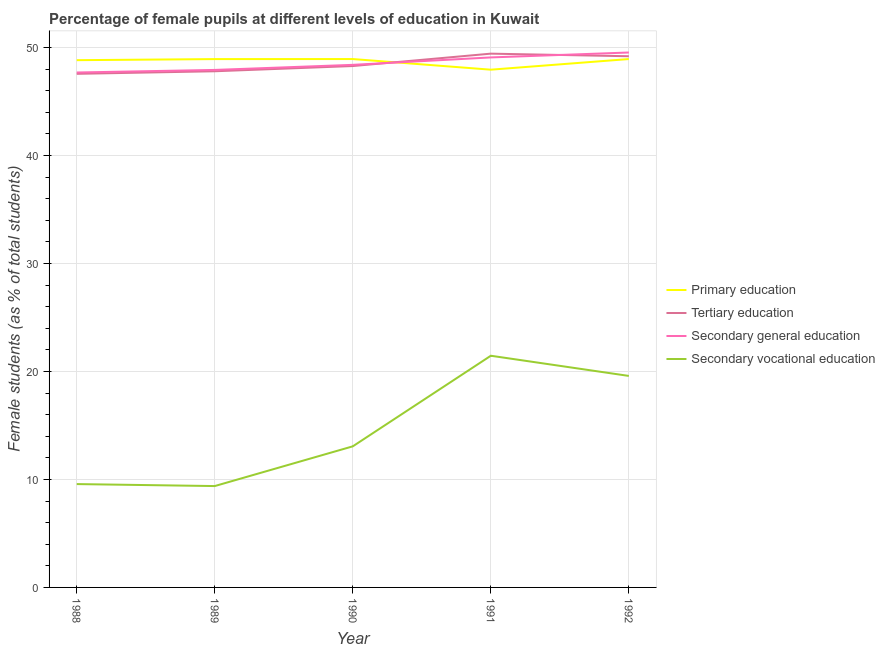Is the number of lines equal to the number of legend labels?
Provide a short and direct response. Yes. What is the percentage of female students in secondary vocational education in 1988?
Keep it short and to the point. 9.57. Across all years, what is the maximum percentage of female students in secondary education?
Your answer should be very brief. 49.53. Across all years, what is the minimum percentage of female students in tertiary education?
Keep it short and to the point. 47.55. In which year was the percentage of female students in secondary vocational education minimum?
Provide a succinct answer. 1989. What is the total percentage of female students in primary education in the graph?
Your response must be concise. 243.52. What is the difference between the percentage of female students in secondary vocational education in 1989 and that in 1991?
Offer a terse response. -12.07. What is the difference between the percentage of female students in tertiary education in 1991 and the percentage of female students in secondary education in 1990?
Your answer should be compact. 1.04. What is the average percentage of female students in secondary vocational education per year?
Your answer should be very brief. 14.61. In the year 1988, what is the difference between the percentage of female students in secondary vocational education and percentage of female students in primary education?
Offer a very short reply. -39.25. What is the ratio of the percentage of female students in primary education in 1990 to that in 1992?
Keep it short and to the point. 1. What is the difference between the highest and the second highest percentage of female students in tertiary education?
Provide a succinct answer. 0.24. What is the difference between the highest and the lowest percentage of female students in primary education?
Provide a short and direct response. 0.98. Is the sum of the percentage of female students in secondary vocational education in 1990 and 1992 greater than the maximum percentage of female students in secondary education across all years?
Provide a short and direct response. No. Is it the case that in every year, the sum of the percentage of female students in secondary education and percentage of female students in secondary vocational education is greater than the sum of percentage of female students in tertiary education and percentage of female students in primary education?
Your answer should be very brief. No. Is it the case that in every year, the sum of the percentage of female students in primary education and percentage of female students in tertiary education is greater than the percentage of female students in secondary education?
Offer a very short reply. Yes. Does the percentage of female students in secondary education monotonically increase over the years?
Your answer should be compact. Yes. How many years are there in the graph?
Ensure brevity in your answer.  5. Does the graph contain grids?
Your answer should be compact. Yes. Where does the legend appear in the graph?
Your answer should be very brief. Center right. How many legend labels are there?
Make the answer very short. 4. How are the legend labels stacked?
Your answer should be compact. Vertical. What is the title of the graph?
Make the answer very short. Percentage of female pupils at different levels of education in Kuwait. Does "Grants and Revenue" appear as one of the legend labels in the graph?
Give a very brief answer. No. What is the label or title of the X-axis?
Give a very brief answer. Year. What is the label or title of the Y-axis?
Offer a terse response. Female students (as % of total students). What is the Female students (as % of total students) of Primary education in 1988?
Offer a very short reply. 48.82. What is the Female students (as % of total students) in Tertiary education in 1988?
Offer a very short reply. 47.55. What is the Female students (as % of total students) of Secondary general education in 1988?
Give a very brief answer. 47.68. What is the Female students (as % of total students) of Secondary vocational education in 1988?
Give a very brief answer. 9.57. What is the Female students (as % of total students) in Primary education in 1989?
Make the answer very short. 48.92. What is the Female students (as % of total students) of Tertiary education in 1989?
Provide a succinct answer. 47.79. What is the Female students (as % of total students) of Secondary general education in 1989?
Provide a short and direct response. 47.92. What is the Female students (as % of total students) in Secondary vocational education in 1989?
Provide a short and direct response. 9.39. What is the Female students (as % of total students) of Primary education in 1990?
Provide a succinct answer. 48.92. What is the Female students (as % of total students) of Tertiary education in 1990?
Ensure brevity in your answer.  48.28. What is the Female students (as % of total students) of Secondary general education in 1990?
Keep it short and to the point. 48.38. What is the Female students (as % of total students) in Secondary vocational education in 1990?
Your answer should be very brief. 13.06. What is the Female students (as % of total students) in Primary education in 1991?
Give a very brief answer. 47.94. What is the Female students (as % of total students) in Tertiary education in 1991?
Your answer should be very brief. 49.42. What is the Female students (as % of total students) in Secondary general education in 1991?
Give a very brief answer. 49.07. What is the Female students (as % of total students) in Secondary vocational education in 1991?
Make the answer very short. 21.45. What is the Female students (as % of total students) of Primary education in 1992?
Offer a very short reply. 48.92. What is the Female students (as % of total students) in Tertiary education in 1992?
Keep it short and to the point. 49.18. What is the Female students (as % of total students) in Secondary general education in 1992?
Your answer should be very brief. 49.53. What is the Female students (as % of total students) in Secondary vocational education in 1992?
Your response must be concise. 19.58. Across all years, what is the maximum Female students (as % of total students) in Primary education?
Provide a succinct answer. 48.92. Across all years, what is the maximum Female students (as % of total students) in Tertiary education?
Make the answer very short. 49.42. Across all years, what is the maximum Female students (as % of total students) in Secondary general education?
Your response must be concise. 49.53. Across all years, what is the maximum Female students (as % of total students) in Secondary vocational education?
Keep it short and to the point. 21.45. Across all years, what is the minimum Female students (as % of total students) of Primary education?
Make the answer very short. 47.94. Across all years, what is the minimum Female students (as % of total students) in Tertiary education?
Ensure brevity in your answer.  47.55. Across all years, what is the minimum Female students (as % of total students) in Secondary general education?
Offer a very short reply. 47.68. Across all years, what is the minimum Female students (as % of total students) in Secondary vocational education?
Make the answer very short. 9.39. What is the total Female students (as % of total students) of Primary education in the graph?
Offer a very short reply. 243.52. What is the total Female students (as % of total students) of Tertiary education in the graph?
Make the answer very short. 242.22. What is the total Female students (as % of total students) of Secondary general education in the graph?
Give a very brief answer. 242.58. What is the total Female students (as % of total students) of Secondary vocational education in the graph?
Offer a terse response. 73.05. What is the difference between the Female students (as % of total students) of Primary education in 1988 and that in 1989?
Make the answer very short. -0.1. What is the difference between the Female students (as % of total students) of Tertiary education in 1988 and that in 1989?
Offer a very short reply. -0.24. What is the difference between the Female students (as % of total students) in Secondary general education in 1988 and that in 1989?
Offer a terse response. -0.24. What is the difference between the Female students (as % of total students) in Secondary vocational education in 1988 and that in 1989?
Offer a terse response. 0.18. What is the difference between the Female students (as % of total students) of Primary education in 1988 and that in 1990?
Provide a short and direct response. -0.1. What is the difference between the Female students (as % of total students) of Tertiary education in 1988 and that in 1990?
Provide a succinct answer. -0.72. What is the difference between the Female students (as % of total students) in Secondary general education in 1988 and that in 1990?
Your answer should be compact. -0.71. What is the difference between the Female students (as % of total students) in Secondary vocational education in 1988 and that in 1990?
Your answer should be very brief. -3.49. What is the difference between the Female students (as % of total students) in Primary education in 1988 and that in 1991?
Your answer should be very brief. 0.88. What is the difference between the Female students (as % of total students) of Tertiary education in 1988 and that in 1991?
Your answer should be very brief. -1.87. What is the difference between the Female students (as % of total students) in Secondary general education in 1988 and that in 1991?
Keep it short and to the point. -1.4. What is the difference between the Female students (as % of total students) in Secondary vocational education in 1988 and that in 1991?
Your response must be concise. -11.88. What is the difference between the Female students (as % of total students) in Primary education in 1988 and that in 1992?
Ensure brevity in your answer.  -0.1. What is the difference between the Female students (as % of total students) in Tertiary education in 1988 and that in 1992?
Ensure brevity in your answer.  -1.63. What is the difference between the Female students (as % of total students) of Secondary general education in 1988 and that in 1992?
Provide a short and direct response. -1.85. What is the difference between the Female students (as % of total students) in Secondary vocational education in 1988 and that in 1992?
Make the answer very short. -10.01. What is the difference between the Female students (as % of total students) in Primary education in 1989 and that in 1990?
Your answer should be very brief. -0. What is the difference between the Female students (as % of total students) in Tertiary education in 1989 and that in 1990?
Offer a very short reply. -0.48. What is the difference between the Female students (as % of total students) in Secondary general education in 1989 and that in 1990?
Offer a terse response. -0.47. What is the difference between the Female students (as % of total students) in Secondary vocational education in 1989 and that in 1990?
Your answer should be very brief. -3.68. What is the difference between the Female students (as % of total students) in Primary education in 1989 and that in 1991?
Ensure brevity in your answer.  0.98. What is the difference between the Female students (as % of total students) in Tertiary education in 1989 and that in 1991?
Ensure brevity in your answer.  -1.63. What is the difference between the Female students (as % of total students) of Secondary general education in 1989 and that in 1991?
Offer a very short reply. -1.16. What is the difference between the Female students (as % of total students) of Secondary vocational education in 1989 and that in 1991?
Provide a succinct answer. -12.07. What is the difference between the Female students (as % of total students) of Primary education in 1989 and that in 1992?
Your answer should be very brief. -0. What is the difference between the Female students (as % of total students) of Tertiary education in 1989 and that in 1992?
Make the answer very short. -1.39. What is the difference between the Female students (as % of total students) of Secondary general education in 1989 and that in 1992?
Your response must be concise. -1.61. What is the difference between the Female students (as % of total students) in Secondary vocational education in 1989 and that in 1992?
Ensure brevity in your answer.  -10.2. What is the difference between the Female students (as % of total students) of Primary education in 1990 and that in 1991?
Make the answer very short. 0.98. What is the difference between the Female students (as % of total students) in Tertiary education in 1990 and that in 1991?
Your response must be concise. -1.15. What is the difference between the Female students (as % of total students) of Secondary general education in 1990 and that in 1991?
Your response must be concise. -0.69. What is the difference between the Female students (as % of total students) in Secondary vocational education in 1990 and that in 1991?
Your answer should be compact. -8.39. What is the difference between the Female students (as % of total students) in Tertiary education in 1990 and that in 1992?
Make the answer very short. -0.91. What is the difference between the Female students (as % of total students) in Secondary general education in 1990 and that in 1992?
Offer a very short reply. -1.14. What is the difference between the Female students (as % of total students) of Secondary vocational education in 1990 and that in 1992?
Keep it short and to the point. -6.52. What is the difference between the Female students (as % of total students) of Primary education in 1991 and that in 1992?
Ensure brevity in your answer.  -0.98. What is the difference between the Female students (as % of total students) in Tertiary education in 1991 and that in 1992?
Provide a short and direct response. 0.24. What is the difference between the Female students (as % of total students) in Secondary general education in 1991 and that in 1992?
Offer a terse response. -0.46. What is the difference between the Female students (as % of total students) of Secondary vocational education in 1991 and that in 1992?
Offer a very short reply. 1.87. What is the difference between the Female students (as % of total students) of Primary education in 1988 and the Female students (as % of total students) of Tertiary education in 1989?
Make the answer very short. 1.03. What is the difference between the Female students (as % of total students) in Primary education in 1988 and the Female students (as % of total students) in Secondary general education in 1989?
Keep it short and to the point. 0.9. What is the difference between the Female students (as % of total students) of Primary education in 1988 and the Female students (as % of total students) of Secondary vocational education in 1989?
Offer a very short reply. 39.43. What is the difference between the Female students (as % of total students) in Tertiary education in 1988 and the Female students (as % of total students) in Secondary general education in 1989?
Offer a very short reply. -0.36. What is the difference between the Female students (as % of total students) in Tertiary education in 1988 and the Female students (as % of total students) in Secondary vocational education in 1989?
Offer a terse response. 38.17. What is the difference between the Female students (as % of total students) of Secondary general education in 1988 and the Female students (as % of total students) of Secondary vocational education in 1989?
Your answer should be very brief. 38.29. What is the difference between the Female students (as % of total students) in Primary education in 1988 and the Female students (as % of total students) in Tertiary education in 1990?
Your response must be concise. 0.54. What is the difference between the Female students (as % of total students) of Primary education in 1988 and the Female students (as % of total students) of Secondary general education in 1990?
Provide a succinct answer. 0.43. What is the difference between the Female students (as % of total students) of Primary education in 1988 and the Female students (as % of total students) of Secondary vocational education in 1990?
Offer a terse response. 35.75. What is the difference between the Female students (as % of total students) of Tertiary education in 1988 and the Female students (as % of total students) of Secondary general education in 1990?
Provide a succinct answer. -0.83. What is the difference between the Female students (as % of total students) of Tertiary education in 1988 and the Female students (as % of total students) of Secondary vocational education in 1990?
Your response must be concise. 34.49. What is the difference between the Female students (as % of total students) of Secondary general education in 1988 and the Female students (as % of total students) of Secondary vocational education in 1990?
Provide a succinct answer. 34.61. What is the difference between the Female students (as % of total students) in Primary education in 1988 and the Female students (as % of total students) in Tertiary education in 1991?
Your answer should be compact. -0.6. What is the difference between the Female students (as % of total students) in Primary education in 1988 and the Female students (as % of total students) in Secondary general education in 1991?
Your answer should be compact. -0.25. What is the difference between the Female students (as % of total students) of Primary education in 1988 and the Female students (as % of total students) of Secondary vocational education in 1991?
Your answer should be compact. 27.37. What is the difference between the Female students (as % of total students) of Tertiary education in 1988 and the Female students (as % of total students) of Secondary general education in 1991?
Offer a very short reply. -1.52. What is the difference between the Female students (as % of total students) in Tertiary education in 1988 and the Female students (as % of total students) in Secondary vocational education in 1991?
Provide a short and direct response. 26.1. What is the difference between the Female students (as % of total students) in Secondary general education in 1988 and the Female students (as % of total students) in Secondary vocational education in 1991?
Give a very brief answer. 26.23. What is the difference between the Female students (as % of total students) of Primary education in 1988 and the Female students (as % of total students) of Tertiary education in 1992?
Make the answer very short. -0.36. What is the difference between the Female students (as % of total students) of Primary education in 1988 and the Female students (as % of total students) of Secondary general education in 1992?
Offer a very short reply. -0.71. What is the difference between the Female students (as % of total students) of Primary education in 1988 and the Female students (as % of total students) of Secondary vocational education in 1992?
Ensure brevity in your answer.  29.23. What is the difference between the Female students (as % of total students) of Tertiary education in 1988 and the Female students (as % of total students) of Secondary general education in 1992?
Give a very brief answer. -1.98. What is the difference between the Female students (as % of total students) in Tertiary education in 1988 and the Female students (as % of total students) in Secondary vocational education in 1992?
Provide a short and direct response. 27.97. What is the difference between the Female students (as % of total students) of Secondary general education in 1988 and the Female students (as % of total students) of Secondary vocational education in 1992?
Keep it short and to the point. 28.09. What is the difference between the Female students (as % of total students) of Primary education in 1989 and the Female students (as % of total students) of Tertiary education in 1990?
Offer a terse response. 0.64. What is the difference between the Female students (as % of total students) of Primary education in 1989 and the Female students (as % of total students) of Secondary general education in 1990?
Your answer should be compact. 0.53. What is the difference between the Female students (as % of total students) of Primary education in 1989 and the Female students (as % of total students) of Secondary vocational education in 1990?
Offer a terse response. 35.85. What is the difference between the Female students (as % of total students) of Tertiary education in 1989 and the Female students (as % of total students) of Secondary general education in 1990?
Your answer should be compact. -0.59. What is the difference between the Female students (as % of total students) in Tertiary education in 1989 and the Female students (as % of total students) in Secondary vocational education in 1990?
Your response must be concise. 34.73. What is the difference between the Female students (as % of total students) of Secondary general education in 1989 and the Female students (as % of total students) of Secondary vocational education in 1990?
Ensure brevity in your answer.  34.85. What is the difference between the Female students (as % of total students) in Primary education in 1989 and the Female students (as % of total students) in Tertiary education in 1991?
Your response must be concise. -0.5. What is the difference between the Female students (as % of total students) of Primary education in 1989 and the Female students (as % of total students) of Secondary general education in 1991?
Your answer should be compact. -0.15. What is the difference between the Female students (as % of total students) in Primary education in 1989 and the Female students (as % of total students) in Secondary vocational education in 1991?
Offer a terse response. 27.47. What is the difference between the Female students (as % of total students) of Tertiary education in 1989 and the Female students (as % of total students) of Secondary general education in 1991?
Provide a succinct answer. -1.28. What is the difference between the Female students (as % of total students) of Tertiary education in 1989 and the Female students (as % of total students) of Secondary vocational education in 1991?
Provide a short and direct response. 26.34. What is the difference between the Female students (as % of total students) in Secondary general education in 1989 and the Female students (as % of total students) in Secondary vocational education in 1991?
Offer a very short reply. 26.46. What is the difference between the Female students (as % of total students) in Primary education in 1989 and the Female students (as % of total students) in Tertiary education in 1992?
Make the answer very short. -0.26. What is the difference between the Female students (as % of total students) of Primary education in 1989 and the Female students (as % of total students) of Secondary general education in 1992?
Give a very brief answer. -0.61. What is the difference between the Female students (as % of total students) in Primary education in 1989 and the Female students (as % of total students) in Secondary vocational education in 1992?
Provide a short and direct response. 29.34. What is the difference between the Female students (as % of total students) in Tertiary education in 1989 and the Female students (as % of total students) in Secondary general education in 1992?
Your answer should be very brief. -1.74. What is the difference between the Female students (as % of total students) in Tertiary education in 1989 and the Female students (as % of total students) in Secondary vocational education in 1992?
Your answer should be very brief. 28.21. What is the difference between the Female students (as % of total students) of Secondary general education in 1989 and the Female students (as % of total students) of Secondary vocational education in 1992?
Your answer should be compact. 28.33. What is the difference between the Female students (as % of total students) of Primary education in 1990 and the Female students (as % of total students) of Tertiary education in 1991?
Make the answer very short. -0.5. What is the difference between the Female students (as % of total students) of Primary education in 1990 and the Female students (as % of total students) of Secondary general education in 1991?
Your answer should be compact. -0.15. What is the difference between the Female students (as % of total students) in Primary education in 1990 and the Female students (as % of total students) in Secondary vocational education in 1991?
Your response must be concise. 27.47. What is the difference between the Female students (as % of total students) in Tertiary education in 1990 and the Female students (as % of total students) in Secondary general education in 1991?
Provide a short and direct response. -0.8. What is the difference between the Female students (as % of total students) in Tertiary education in 1990 and the Female students (as % of total students) in Secondary vocational education in 1991?
Your response must be concise. 26.82. What is the difference between the Female students (as % of total students) in Secondary general education in 1990 and the Female students (as % of total students) in Secondary vocational education in 1991?
Make the answer very short. 26.93. What is the difference between the Female students (as % of total students) in Primary education in 1990 and the Female students (as % of total students) in Tertiary education in 1992?
Give a very brief answer. -0.26. What is the difference between the Female students (as % of total students) of Primary education in 1990 and the Female students (as % of total students) of Secondary general education in 1992?
Make the answer very short. -0.61. What is the difference between the Female students (as % of total students) in Primary education in 1990 and the Female students (as % of total students) in Secondary vocational education in 1992?
Ensure brevity in your answer.  29.34. What is the difference between the Female students (as % of total students) in Tertiary education in 1990 and the Female students (as % of total students) in Secondary general education in 1992?
Make the answer very short. -1.25. What is the difference between the Female students (as % of total students) in Tertiary education in 1990 and the Female students (as % of total students) in Secondary vocational education in 1992?
Your answer should be compact. 28.69. What is the difference between the Female students (as % of total students) of Secondary general education in 1990 and the Female students (as % of total students) of Secondary vocational education in 1992?
Provide a short and direct response. 28.8. What is the difference between the Female students (as % of total students) of Primary education in 1991 and the Female students (as % of total students) of Tertiary education in 1992?
Keep it short and to the point. -1.24. What is the difference between the Female students (as % of total students) in Primary education in 1991 and the Female students (as % of total students) in Secondary general education in 1992?
Make the answer very short. -1.59. What is the difference between the Female students (as % of total students) of Primary education in 1991 and the Female students (as % of total students) of Secondary vocational education in 1992?
Make the answer very short. 28.35. What is the difference between the Female students (as % of total students) of Tertiary education in 1991 and the Female students (as % of total students) of Secondary general education in 1992?
Your answer should be compact. -0.11. What is the difference between the Female students (as % of total students) in Tertiary education in 1991 and the Female students (as % of total students) in Secondary vocational education in 1992?
Keep it short and to the point. 29.84. What is the difference between the Female students (as % of total students) of Secondary general education in 1991 and the Female students (as % of total students) of Secondary vocational education in 1992?
Your answer should be compact. 29.49. What is the average Female students (as % of total students) of Primary education per year?
Keep it short and to the point. 48.7. What is the average Female students (as % of total students) of Tertiary education per year?
Offer a terse response. 48.44. What is the average Female students (as % of total students) of Secondary general education per year?
Make the answer very short. 48.52. What is the average Female students (as % of total students) of Secondary vocational education per year?
Ensure brevity in your answer.  14.61. In the year 1988, what is the difference between the Female students (as % of total students) of Primary education and Female students (as % of total students) of Tertiary education?
Give a very brief answer. 1.26. In the year 1988, what is the difference between the Female students (as % of total students) in Primary education and Female students (as % of total students) in Secondary general education?
Keep it short and to the point. 1.14. In the year 1988, what is the difference between the Female students (as % of total students) of Primary education and Female students (as % of total students) of Secondary vocational education?
Provide a succinct answer. 39.25. In the year 1988, what is the difference between the Female students (as % of total students) in Tertiary education and Female students (as % of total students) in Secondary general education?
Provide a short and direct response. -0.12. In the year 1988, what is the difference between the Female students (as % of total students) of Tertiary education and Female students (as % of total students) of Secondary vocational education?
Give a very brief answer. 37.98. In the year 1988, what is the difference between the Female students (as % of total students) of Secondary general education and Female students (as % of total students) of Secondary vocational education?
Your response must be concise. 38.11. In the year 1989, what is the difference between the Female students (as % of total students) of Primary education and Female students (as % of total students) of Tertiary education?
Your answer should be compact. 1.13. In the year 1989, what is the difference between the Female students (as % of total students) of Primary education and Female students (as % of total students) of Secondary general education?
Your answer should be very brief. 1. In the year 1989, what is the difference between the Female students (as % of total students) in Primary education and Female students (as % of total students) in Secondary vocational education?
Keep it short and to the point. 39.53. In the year 1989, what is the difference between the Female students (as % of total students) of Tertiary education and Female students (as % of total students) of Secondary general education?
Provide a short and direct response. -0.13. In the year 1989, what is the difference between the Female students (as % of total students) of Tertiary education and Female students (as % of total students) of Secondary vocational education?
Your response must be concise. 38.4. In the year 1989, what is the difference between the Female students (as % of total students) of Secondary general education and Female students (as % of total students) of Secondary vocational education?
Offer a very short reply. 38.53. In the year 1990, what is the difference between the Female students (as % of total students) of Primary education and Female students (as % of total students) of Tertiary education?
Offer a very short reply. 0.65. In the year 1990, what is the difference between the Female students (as % of total students) in Primary education and Female students (as % of total students) in Secondary general education?
Your answer should be very brief. 0.54. In the year 1990, what is the difference between the Female students (as % of total students) of Primary education and Female students (as % of total students) of Secondary vocational education?
Ensure brevity in your answer.  35.86. In the year 1990, what is the difference between the Female students (as % of total students) in Tertiary education and Female students (as % of total students) in Secondary general education?
Your answer should be compact. -0.11. In the year 1990, what is the difference between the Female students (as % of total students) in Tertiary education and Female students (as % of total students) in Secondary vocational education?
Offer a very short reply. 35.21. In the year 1990, what is the difference between the Female students (as % of total students) in Secondary general education and Female students (as % of total students) in Secondary vocational education?
Give a very brief answer. 35.32. In the year 1991, what is the difference between the Female students (as % of total students) of Primary education and Female students (as % of total students) of Tertiary education?
Keep it short and to the point. -1.48. In the year 1991, what is the difference between the Female students (as % of total students) in Primary education and Female students (as % of total students) in Secondary general education?
Make the answer very short. -1.13. In the year 1991, what is the difference between the Female students (as % of total students) in Primary education and Female students (as % of total students) in Secondary vocational education?
Offer a terse response. 26.49. In the year 1991, what is the difference between the Female students (as % of total students) of Tertiary education and Female students (as % of total students) of Secondary general education?
Your answer should be very brief. 0.35. In the year 1991, what is the difference between the Female students (as % of total students) of Tertiary education and Female students (as % of total students) of Secondary vocational education?
Provide a succinct answer. 27.97. In the year 1991, what is the difference between the Female students (as % of total students) in Secondary general education and Female students (as % of total students) in Secondary vocational education?
Your response must be concise. 27.62. In the year 1992, what is the difference between the Female students (as % of total students) of Primary education and Female students (as % of total students) of Tertiary education?
Give a very brief answer. -0.26. In the year 1992, what is the difference between the Female students (as % of total students) in Primary education and Female students (as % of total students) in Secondary general education?
Your answer should be compact. -0.61. In the year 1992, what is the difference between the Female students (as % of total students) in Primary education and Female students (as % of total students) in Secondary vocational education?
Provide a succinct answer. 29.34. In the year 1992, what is the difference between the Female students (as % of total students) in Tertiary education and Female students (as % of total students) in Secondary general education?
Provide a short and direct response. -0.35. In the year 1992, what is the difference between the Female students (as % of total students) in Tertiary education and Female students (as % of total students) in Secondary vocational education?
Offer a very short reply. 29.6. In the year 1992, what is the difference between the Female students (as % of total students) in Secondary general education and Female students (as % of total students) in Secondary vocational education?
Keep it short and to the point. 29.95. What is the ratio of the Female students (as % of total students) in Primary education in 1988 to that in 1989?
Make the answer very short. 1. What is the ratio of the Female students (as % of total students) in Secondary vocational education in 1988 to that in 1989?
Offer a very short reply. 1.02. What is the ratio of the Female students (as % of total students) in Primary education in 1988 to that in 1990?
Give a very brief answer. 1. What is the ratio of the Female students (as % of total students) in Tertiary education in 1988 to that in 1990?
Keep it short and to the point. 0.98. What is the ratio of the Female students (as % of total students) in Secondary general education in 1988 to that in 1990?
Give a very brief answer. 0.99. What is the ratio of the Female students (as % of total students) of Secondary vocational education in 1988 to that in 1990?
Give a very brief answer. 0.73. What is the ratio of the Female students (as % of total students) of Primary education in 1988 to that in 1991?
Make the answer very short. 1.02. What is the ratio of the Female students (as % of total students) in Tertiary education in 1988 to that in 1991?
Give a very brief answer. 0.96. What is the ratio of the Female students (as % of total students) of Secondary general education in 1988 to that in 1991?
Your response must be concise. 0.97. What is the ratio of the Female students (as % of total students) of Secondary vocational education in 1988 to that in 1991?
Give a very brief answer. 0.45. What is the ratio of the Female students (as % of total students) of Primary education in 1988 to that in 1992?
Make the answer very short. 1. What is the ratio of the Female students (as % of total students) of Tertiary education in 1988 to that in 1992?
Provide a short and direct response. 0.97. What is the ratio of the Female students (as % of total students) of Secondary general education in 1988 to that in 1992?
Ensure brevity in your answer.  0.96. What is the ratio of the Female students (as % of total students) of Secondary vocational education in 1988 to that in 1992?
Provide a succinct answer. 0.49. What is the ratio of the Female students (as % of total students) of Primary education in 1989 to that in 1990?
Give a very brief answer. 1. What is the ratio of the Female students (as % of total students) in Tertiary education in 1989 to that in 1990?
Ensure brevity in your answer.  0.99. What is the ratio of the Female students (as % of total students) of Secondary general education in 1989 to that in 1990?
Give a very brief answer. 0.99. What is the ratio of the Female students (as % of total students) in Secondary vocational education in 1989 to that in 1990?
Offer a terse response. 0.72. What is the ratio of the Female students (as % of total students) of Primary education in 1989 to that in 1991?
Provide a succinct answer. 1.02. What is the ratio of the Female students (as % of total students) of Secondary general education in 1989 to that in 1991?
Your answer should be very brief. 0.98. What is the ratio of the Female students (as % of total students) in Secondary vocational education in 1989 to that in 1991?
Offer a terse response. 0.44. What is the ratio of the Female students (as % of total students) in Tertiary education in 1989 to that in 1992?
Offer a very short reply. 0.97. What is the ratio of the Female students (as % of total students) in Secondary general education in 1989 to that in 1992?
Offer a terse response. 0.97. What is the ratio of the Female students (as % of total students) of Secondary vocational education in 1989 to that in 1992?
Provide a succinct answer. 0.48. What is the ratio of the Female students (as % of total students) in Primary education in 1990 to that in 1991?
Your answer should be very brief. 1.02. What is the ratio of the Female students (as % of total students) of Tertiary education in 1990 to that in 1991?
Make the answer very short. 0.98. What is the ratio of the Female students (as % of total students) in Secondary general education in 1990 to that in 1991?
Your answer should be compact. 0.99. What is the ratio of the Female students (as % of total students) of Secondary vocational education in 1990 to that in 1991?
Offer a very short reply. 0.61. What is the ratio of the Female students (as % of total students) of Tertiary education in 1990 to that in 1992?
Give a very brief answer. 0.98. What is the ratio of the Female students (as % of total students) of Secondary general education in 1990 to that in 1992?
Your response must be concise. 0.98. What is the ratio of the Female students (as % of total students) in Secondary vocational education in 1990 to that in 1992?
Your answer should be very brief. 0.67. What is the ratio of the Female students (as % of total students) in Primary education in 1991 to that in 1992?
Offer a terse response. 0.98. What is the ratio of the Female students (as % of total students) of Secondary vocational education in 1991 to that in 1992?
Offer a very short reply. 1.1. What is the difference between the highest and the second highest Female students (as % of total students) in Tertiary education?
Make the answer very short. 0.24. What is the difference between the highest and the second highest Female students (as % of total students) of Secondary general education?
Your response must be concise. 0.46. What is the difference between the highest and the second highest Female students (as % of total students) in Secondary vocational education?
Keep it short and to the point. 1.87. What is the difference between the highest and the lowest Female students (as % of total students) of Tertiary education?
Give a very brief answer. 1.87. What is the difference between the highest and the lowest Female students (as % of total students) in Secondary general education?
Keep it short and to the point. 1.85. What is the difference between the highest and the lowest Female students (as % of total students) in Secondary vocational education?
Your response must be concise. 12.07. 